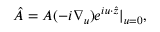<formula> <loc_0><loc_0><loc_500><loc_500>\hat { A } = A ( - i \nabla _ { u } ) e ^ { i u \cdot \hat { z } } | _ { u = 0 } ,</formula> 